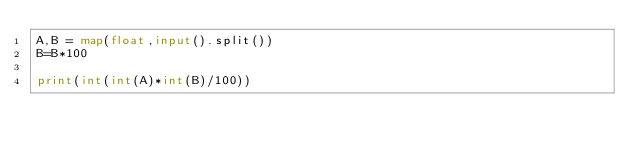<code> <loc_0><loc_0><loc_500><loc_500><_Python_>A,B = map(float,input().split())
B=B*100

print(int(int(A)*int(B)/100))</code> 